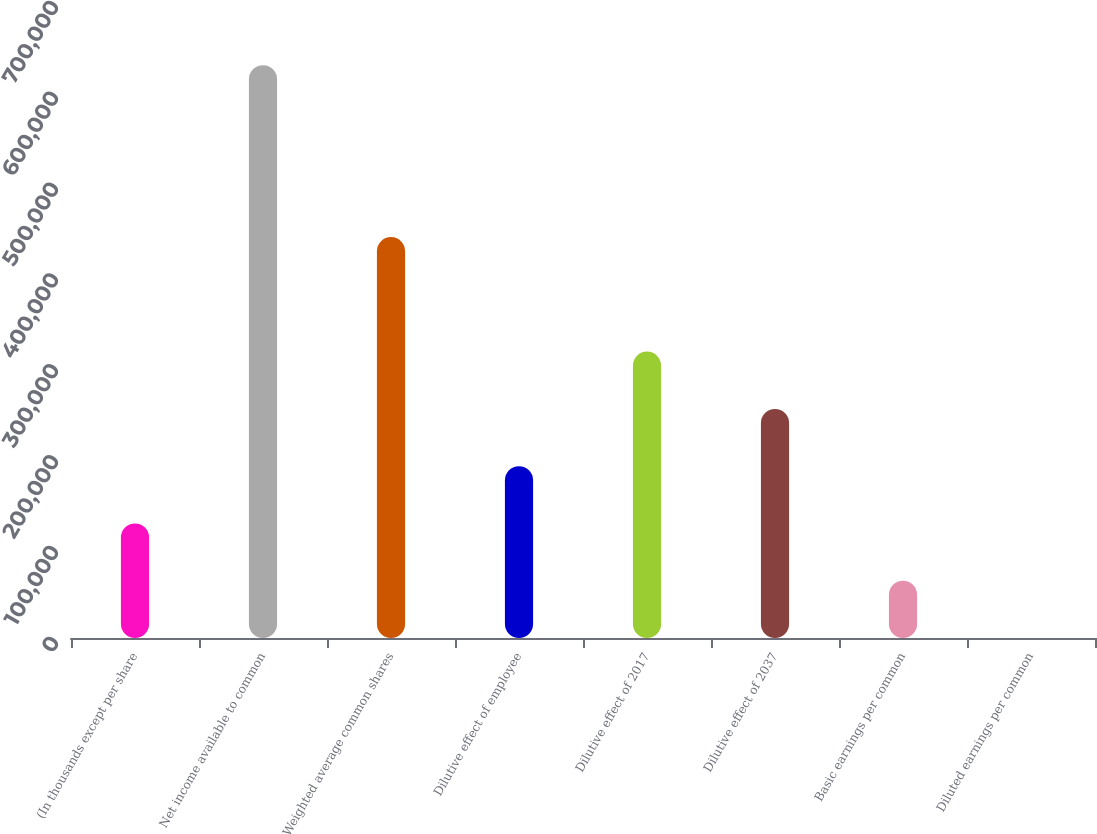<chart> <loc_0><loc_0><loc_500><loc_500><bar_chart><fcel>(In thousands except per share<fcel>Net income available to common<fcel>Weighted average common shares<fcel>Dilutive effect of employee<fcel>Dilutive effect of 2017<fcel>Dilutive effect of 2037<fcel>Basic earnings per common<fcel>Diluted earnings per common<nl><fcel>126079<fcel>630388<fcel>441272<fcel>189118<fcel>315195<fcel>252157<fcel>63040.8<fcel>2.19<nl></chart> 